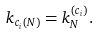<formula> <loc_0><loc_0><loc_500><loc_500>k _ { c _ { i } \left ( N \right ) } = k _ { N } ^ { \left ( c _ { i } \right ) } .</formula> 